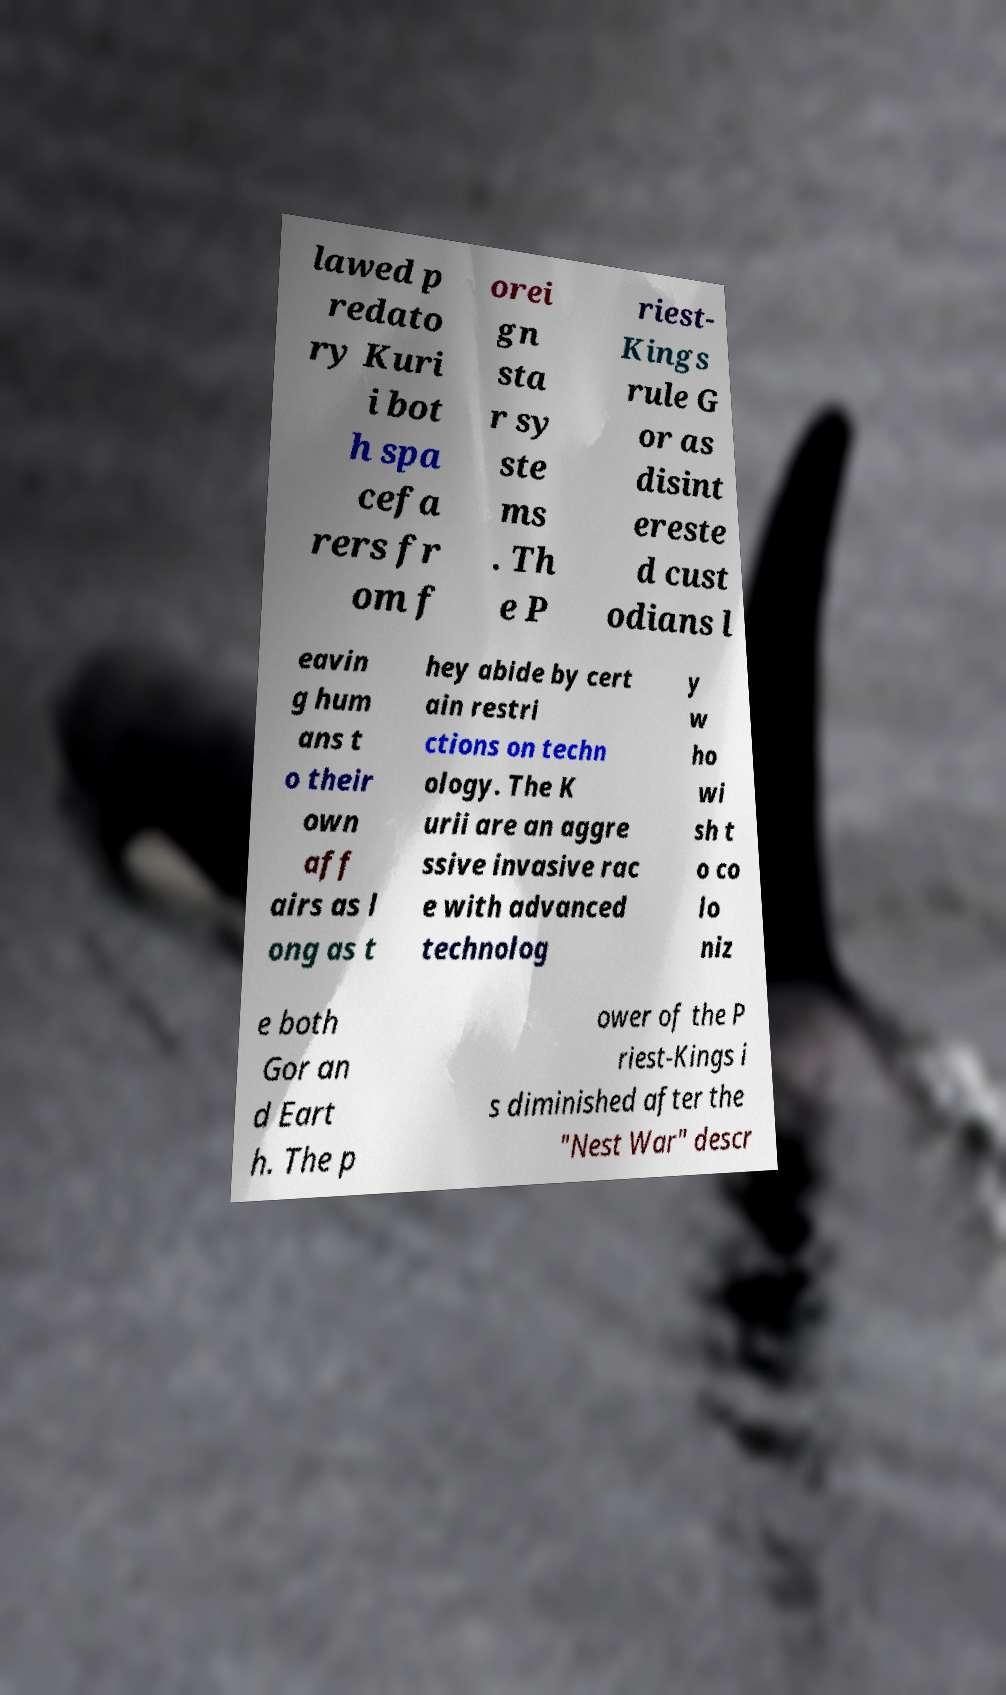Could you assist in decoding the text presented in this image and type it out clearly? lawed p redato ry Kuri i bot h spa cefa rers fr om f orei gn sta r sy ste ms . Th e P riest- Kings rule G or as disint ereste d cust odians l eavin g hum ans t o their own aff airs as l ong as t hey abide by cert ain restri ctions on techn ology. The K urii are an aggre ssive invasive rac e with advanced technolog y w ho wi sh t o co lo niz e both Gor an d Eart h. The p ower of the P riest-Kings i s diminished after the "Nest War" descr 